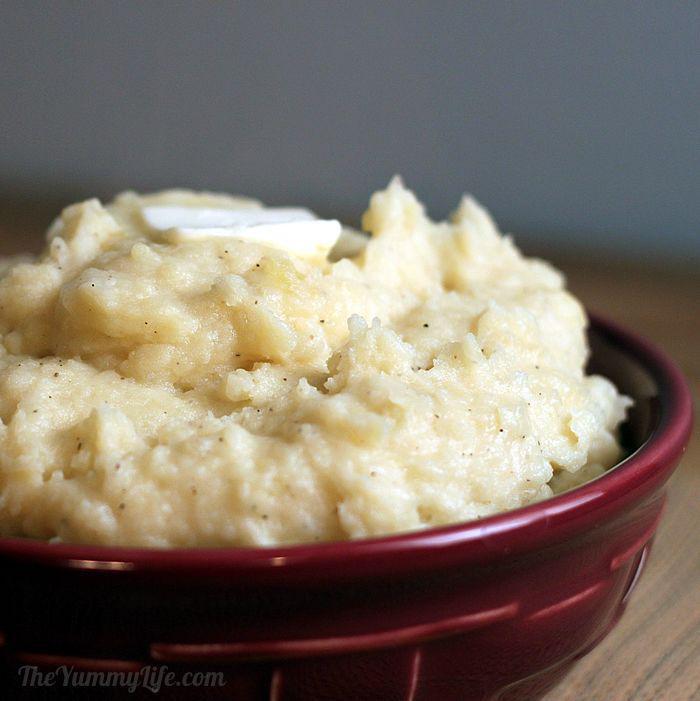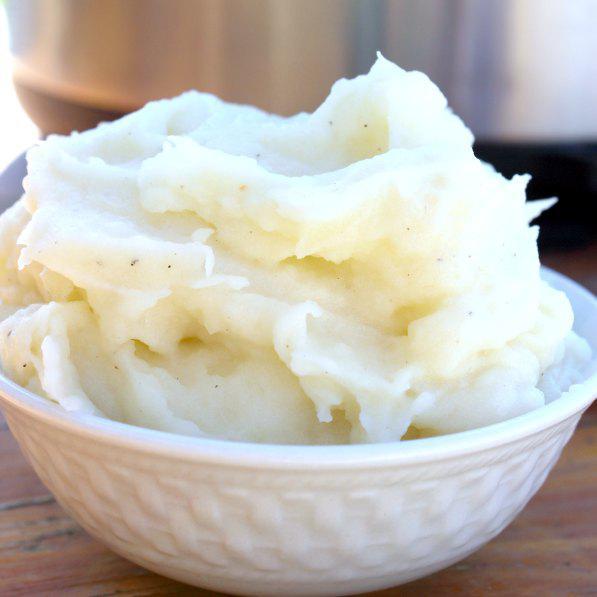The first image is the image on the left, the second image is the image on the right. For the images displayed, is the sentence "A spoon is visible next to one of the dishes of food." factually correct? Answer yes or no. No. 